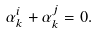Convert formula to latex. <formula><loc_0><loc_0><loc_500><loc_500>\alpha _ { k } ^ { i } + \alpha _ { k } ^ { j } = 0 .</formula> 